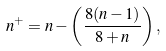Convert formula to latex. <formula><loc_0><loc_0><loc_500><loc_500>n ^ { + } = n - \left ( \frac { 8 ( n - 1 ) } { 8 + n } \right ) ,</formula> 